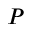<formula> <loc_0><loc_0><loc_500><loc_500>P</formula> 